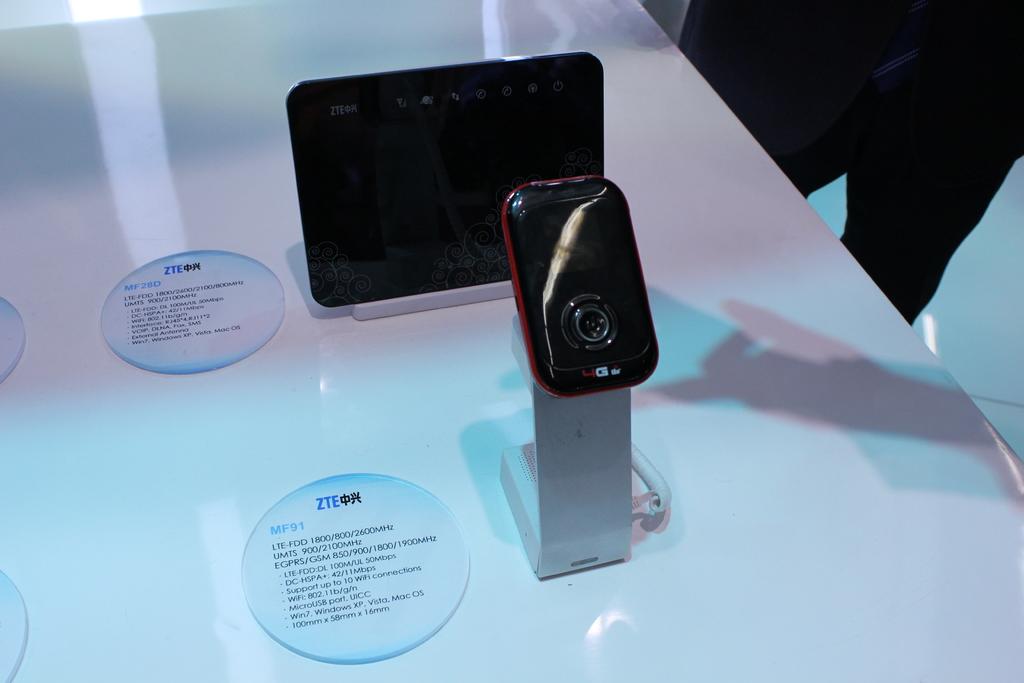What is written under zte on the circles?
Make the answer very short. Mf91. 